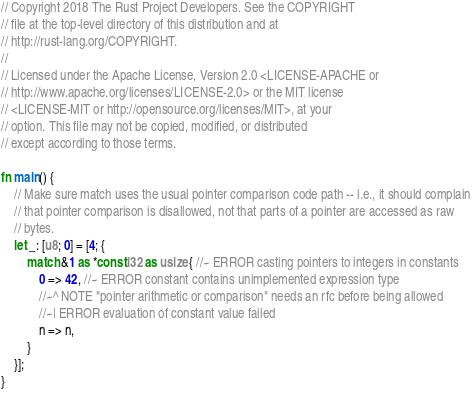<code> <loc_0><loc_0><loc_500><loc_500><_Rust_>// Copyright 2018 The Rust Project Developers. See the COPYRIGHT
// file at the top-level directory of this distribution and at
// http://rust-lang.org/COPYRIGHT.
//
// Licensed under the Apache License, Version 2.0 <LICENSE-APACHE or
// http://www.apache.org/licenses/LICENSE-2.0> or the MIT license
// <LICENSE-MIT or http://opensource.org/licenses/MIT>, at your
// option. This file may not be copied, modified, or distributed
// except according to those terms.

fn main() {
    // Make sure match uses the usual pointer comparison code path -- i.e., it should complain
    // that pointer comparison is disallowed, not that parts of a pointer are accessed as raw
    // bytes.
    let _: [u8; 0] = [4; {
        match &1 as *const i32 as usize { //~ ERROR casting pointers to integers in constants
            0 => 42, //~ ERROR constant contains unimplemented expression type
            //~^ NOTE "pointer arithmetic or comparison" needs an rfc before being allowed
            //~| ERROR evaluation of constant value failed
            n => n,
        }
    }];
}
</code> 